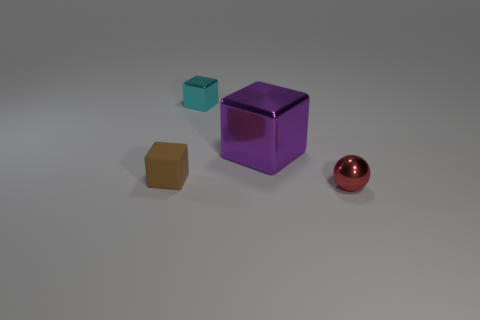Add 1 tiny things. How many objects exist? 5 Subtract all cubes. How many objects are left? 1 Add 2 big cubes. How many big cubes are left? 3 Add 1 big purple cubes. How many big purple cubes exist? 2 Subtract 1 brown blocks. How many objects are left? 3 Subtract all tiny metallic cubes. Subtract all tiny cyan metal things. How many objects are left? 2 